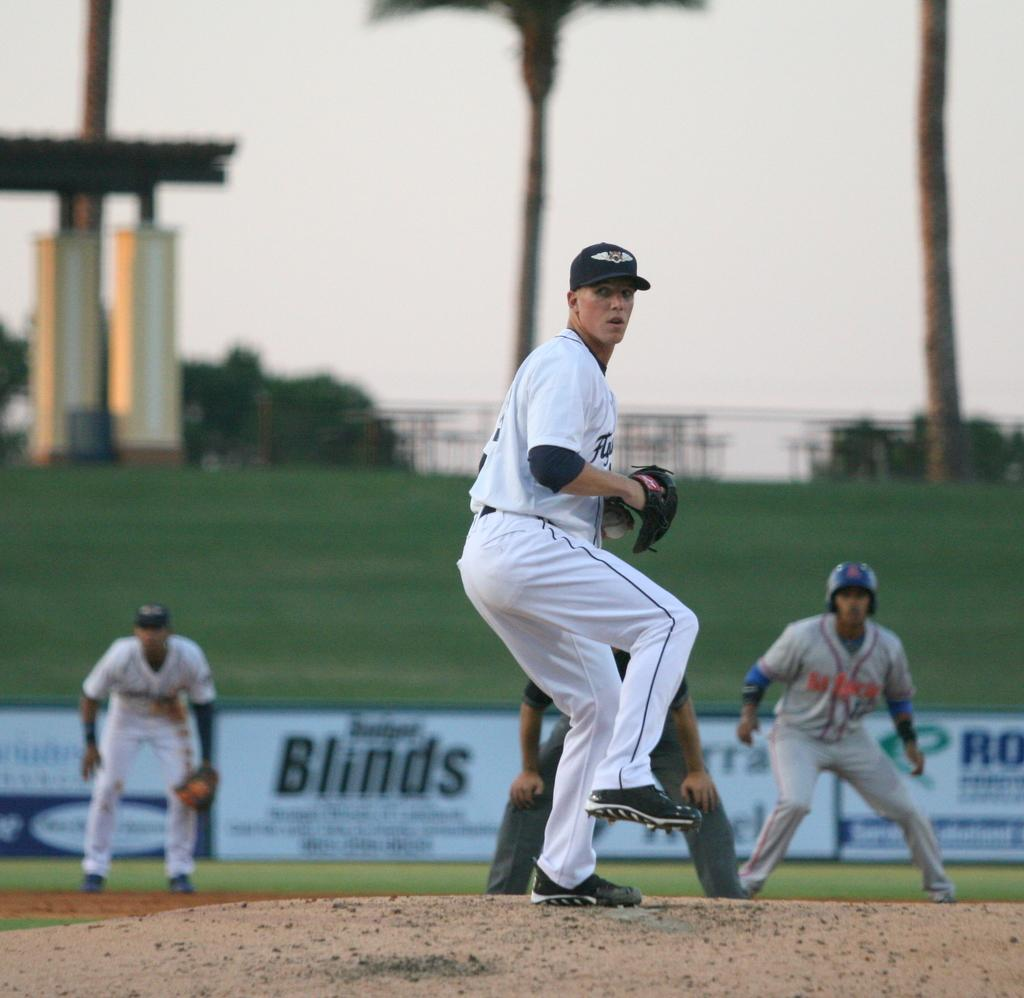<image>
Offer a succinct explanation of the picture presented. A billboard that says Fengxian Cauliflower Festival of Shanghai. 